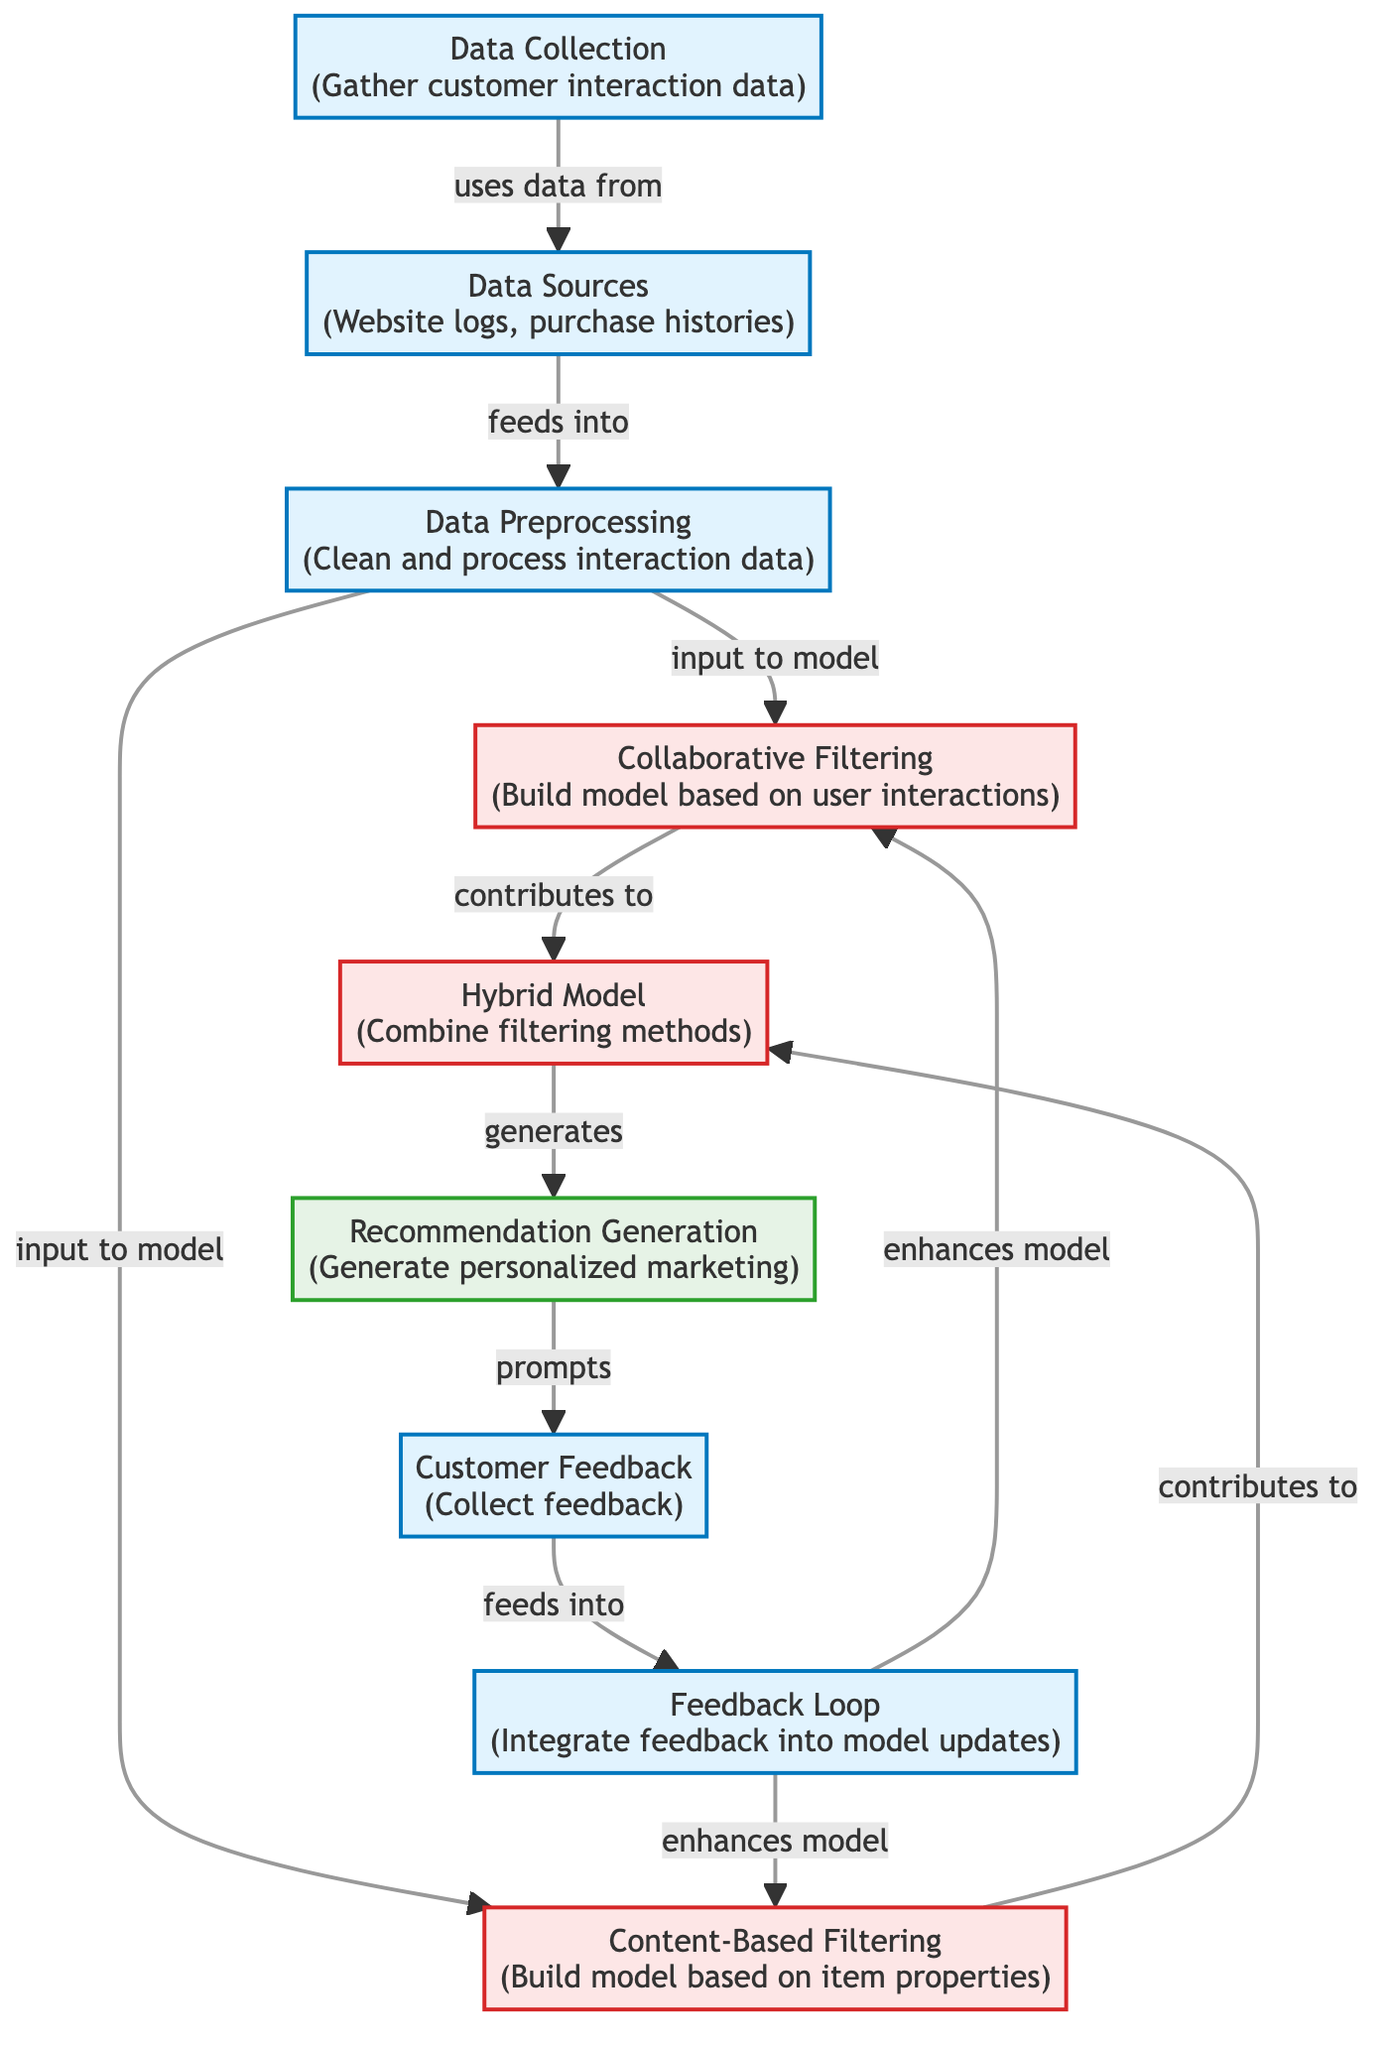What is the first stage in the diagram? The diagram starts with the "Data Collection" stage, which is the initial process of gathering customer interaction data.
Answer: Data Collection How many types of filtering methods are represented? The diagram shows two distinct filtering methods: Collaborative Filtering and Content-Based Filtering, along with a Hybrid Model that combines both methods.
Answer: Two What feeds into the Hybrid Model? The Hybrid Model receives contributions from both the Collaborative Filtering and Content-Based Filtering methods as indicated by the connecting arrows from both nodes.
Answer: Collaborative Filtering and Content-Based Filtering What happens after the recommendation generation stage? Following the Recommendation Generation stage, there is a Customer Feedback stage which collects user feedback based on the generated recommendations.
Answer: Customer Feedback What enhances the models in the feedback loop? The Feedback Loop is designed to enhance both the Collaborative Filtering and Content-Based Filtering models utilizing the feedback received from the Customer Feedback stage.
Answer: Enhances models Which data source is mentioned in the diagram? The diagram lists "Website logs" and "purchase histories" as part of the Data Sources from which customer interaction data is derived.
Answer: Website logs and purchase histories What is the role of data preprocessing in the diagram? Data Preprocessing serves as an essential step that involves cleaning and processing the interaction data before it's fed into the filtering models, ensuring data quality and relevance.
Answer: Clean and process interaction data How many nodes are there in total within the process stages? Counting all the distinct process nodes, there are four main process nodes: Data Collection, Data Sources, Data Preprocessing, and Customer Feedback.
Answer: Four 